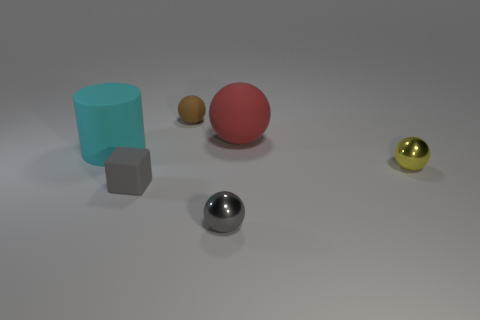Subtract all small brown spheres. How many spheres are left? 3 Add 2 small yellow objects. How many objects exist? 8 Subtract all red balls. How many balls are left? 3 Subtract 1 balls. How many balls are left? 3 Subtract all brown blocks. How many yellow spheres are left? 1 Add 3 big red matte spheres. How many big red matte spheres exist? 4 Subtract 1 gray blocks. How many objects are left? 5 Subtract all cylinders. How many objects are left? 5 Subtract all red balls. Subtract all green blocks. How many balls are left? 3 Subtract all large cylinders. Subtract all small yellow metallic objects. How many objects are left? 4 